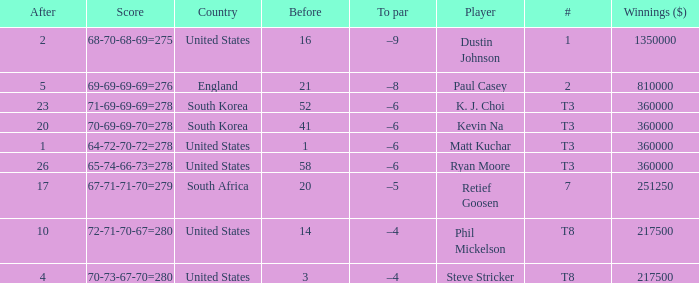What is the # listed when the score is 70-69-69-70=278? T3. 